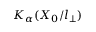Convert formula to latex. <formula><loc_0><loc_0><loc_500><loc_500>K _ { \alpha } ( X _ { 0 } / l _ { \perp } )</formula> 